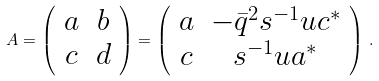<formula> <loc_0><loc_0><loc_500><loc_500>A = \left ( \begin{array} { c c } a & b \\ c & d \end{array} \right ) = \left ( \begin{array} { c c } a & - \bar { q } ^ { 2 } s ^ { - 1 } u c ^ { \ast } \\ c & s ^ { - 1 } u a ^ { \ast } \end{array} \right ) \, .</formula> 